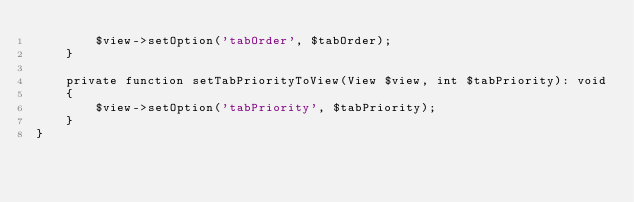Convert code to text. <code><loc_0><loc_0><loc_500><loc_500><_PHP_>        $view->setOption('tabOrder', $tabOrder);
    }

    private function setTabPriorityToView(View $view, int $tabPriority): void
    {
        $view->setOption('tabPriority', $tabPriority);
    }
}
</code> 